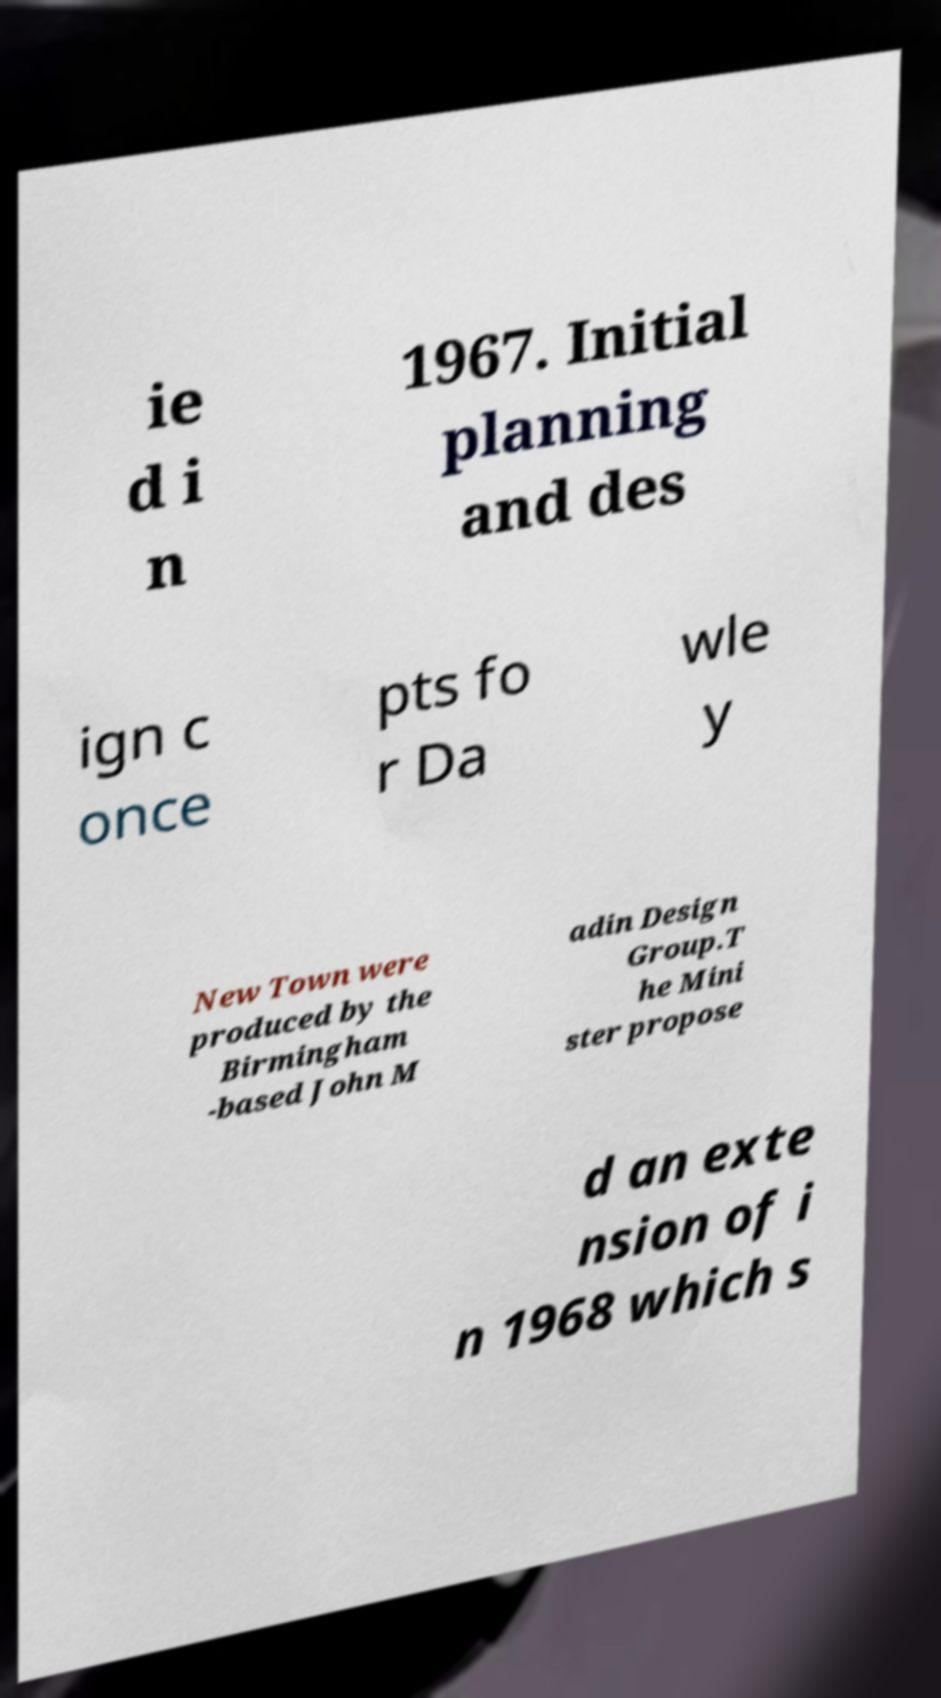What messages or text are displayed in this image? I need them in a readable, typed format. ie d i n 1967. Initial planning and des ign c once pts fo r Da wle y New Town were produced by the Birmingham -based John M adin Design Group.T he Mini ster propose d an exte nsion of i n 1968 which s 